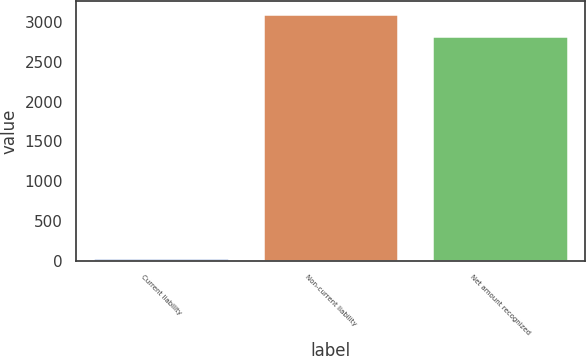<chart> <loc_0><loc_0><loc_500><loc_500><bar_chart><fcel>Current liability<fcel>Non-current liability<fcel>Net amount recognized<nl><fcel>38<fcel>3103.4<fcel>2819<nl></chart> 